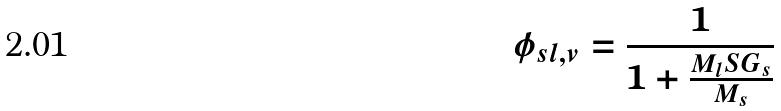Convert formula to latex. <formula><loc_0><loc_0><loc_500><loc_500>\phi _ { s l , v } = \frac { 1 } { 1 + \frac { M _ { l } S G _ { s } } { M _ { s } } }</formula> 